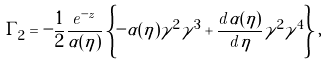<formula> <loc_0><loc_0><loc_500><loc_500>\Gamma _ { 2 } = - \frac { 1 } { 2 } \frac { e ^ { - z } } { \alpha ( \eta ) } \left \{ - \alpha ( \eta ) \gamma ^ { 2 } \gamma ^ { 3 } + \frac { d \alpha ( \eta ) } { d \eta } \gamma ^ { 2 } \gamma ^ { 4 } \right \} ,</formula> 